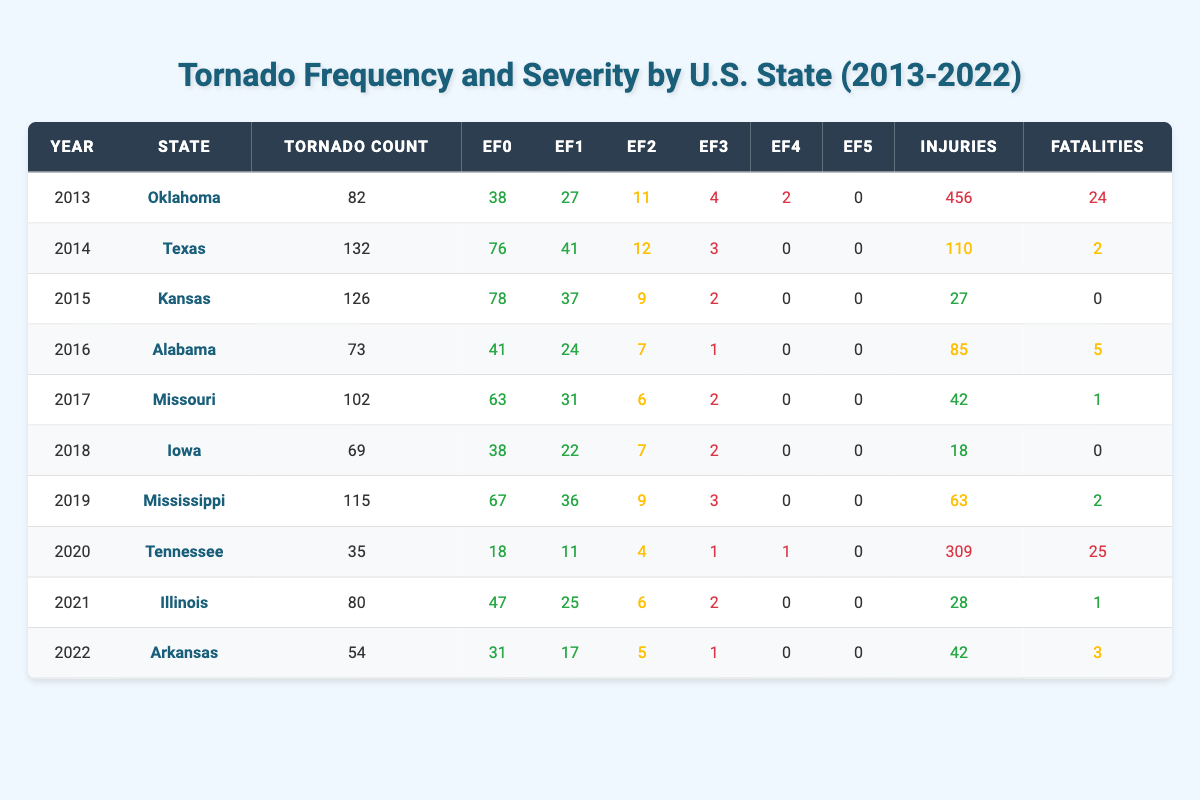What state had the highest tornado count in 2014? From the table, the state with the highest tornado count in 2014 is Texas, which had a total of 132 tornadoes.
Answer: Texas How many EF5 tornadoes occurred in Oklahoma from 2013 to 2022? According to the table, Oklahoma had 0 EF5 tornadoes in 2013 and no other EF5 tornadoes across the subsequent years listed, so the total is 0.
Answer: 0 What is the total number of tornadoes reported in Missouri from 2013 to 2022? By summing the tornado counts for Missouri: 102 (2017) + 0 (other years with no tornadoes listed) = 102. Thus, the total for Missouri in this period is 102.
Answer: 102 Did Arkansas record any EF4 tornadoes in 2022? The table shows that Arkansas had 0 EF4 tornadoes in 2022, so the answer is no.
Answer: No Which state had the most injuries caused by tornadoes in 2020? In 2020, Tennessee had the highest number of injuries at 309 due to tornadoes, according to the table.
Answer: Tennessee What was the average number of EF2 tornadoes across all states listed for the year 2015? The EF2 tornado counts for the listed states in 2015 are Kansas (9). Since there is only one data point, the average number of EF2 tornadoes is 9.
Answer: 9 How many fatalities were recorded in states with at least 100 tornadoes in any given year? Looking at the years, only Texas (2014 with 2 fatalities) and Missouri (2017 with 1 fatality) had at least 100 tornadoes. Thus, the total fatalities are 2 + 1, which equals 3.
Answer: 3 What year had the lowest tornado count, and which state did it occur in? The lowest tornado count was 35, which occurred in Tennessee in 2020, according to the table data.
Answer: 2020, Tennessee What percentage of tornadoes in Oklahoma in 2013 were classified as EF0? In Oklahoma in 2013, there were 82 tornadoes total and 38 were EF0. The percentage is calculated as (38/82) * 100, which is approximately 46.34%.
Answer: 46.34% 